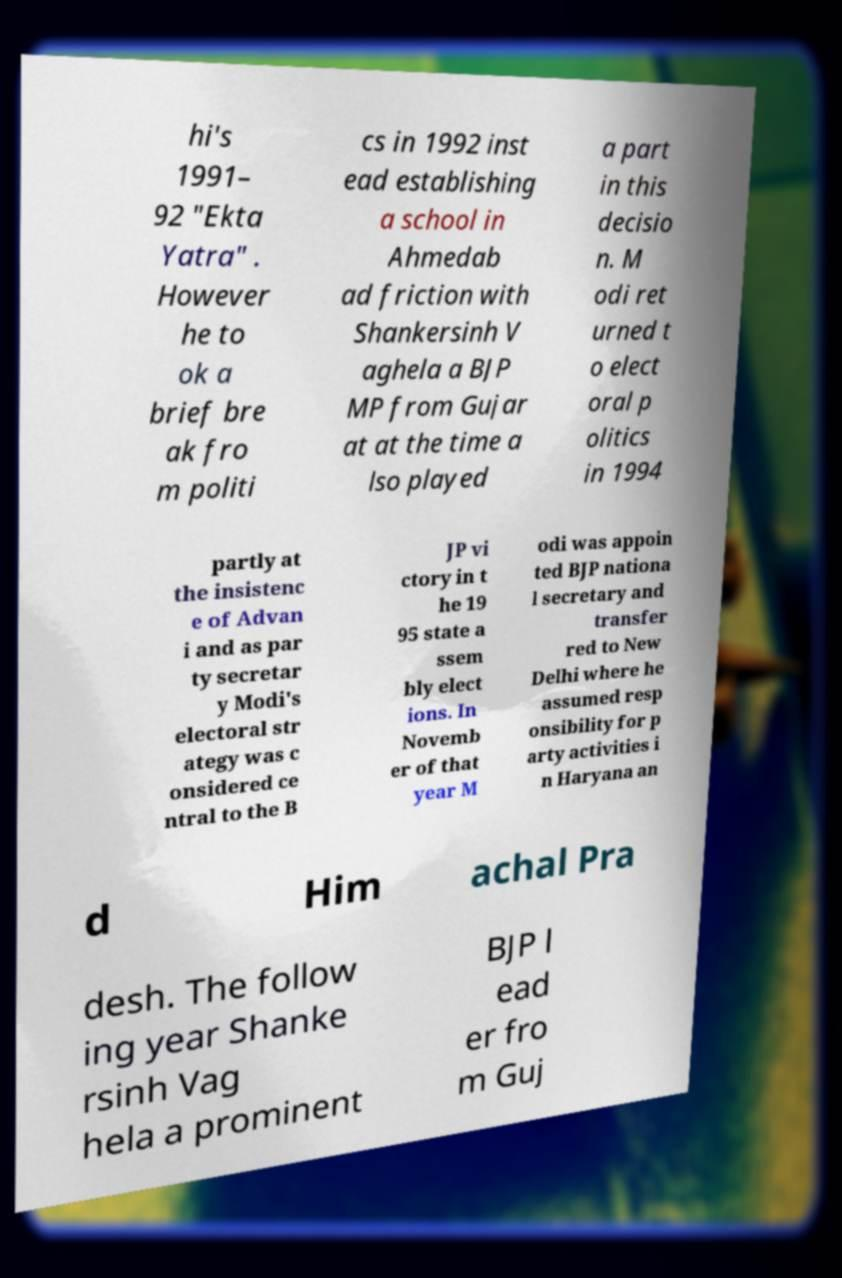For documentation purposes, I need the text within this image transcribed. Could you provide that? hi's 1991– 92 "Ekta Yatra" . However he to ok a brief bre ak fro m politi cs in 1992 inst ead establishing a school in Ahmedab ad friction with Shankersinh V aghela a BJP MP from Gujar at at the time a lso played a part in this decisio n. M odi ret urned t o elect oral p olitics in 1994 partly at the insistenc e of Advan i and as par ty secretar y Modi's electoral str ategy was c onsidered ce ntral to the B JP vi ctory in t he 19 95 state a ssem bly elect ions. In Novemb er of that year M odi was appoin ted BJP nationa l secretary and transfer red to New Delhi where he assumed resp onsibility for p arty activities i n Haryana an d Him achal Pra desh. The follow ing year Shanke rsinh Vag hela a prominent BJP l ead er fro m Guj 